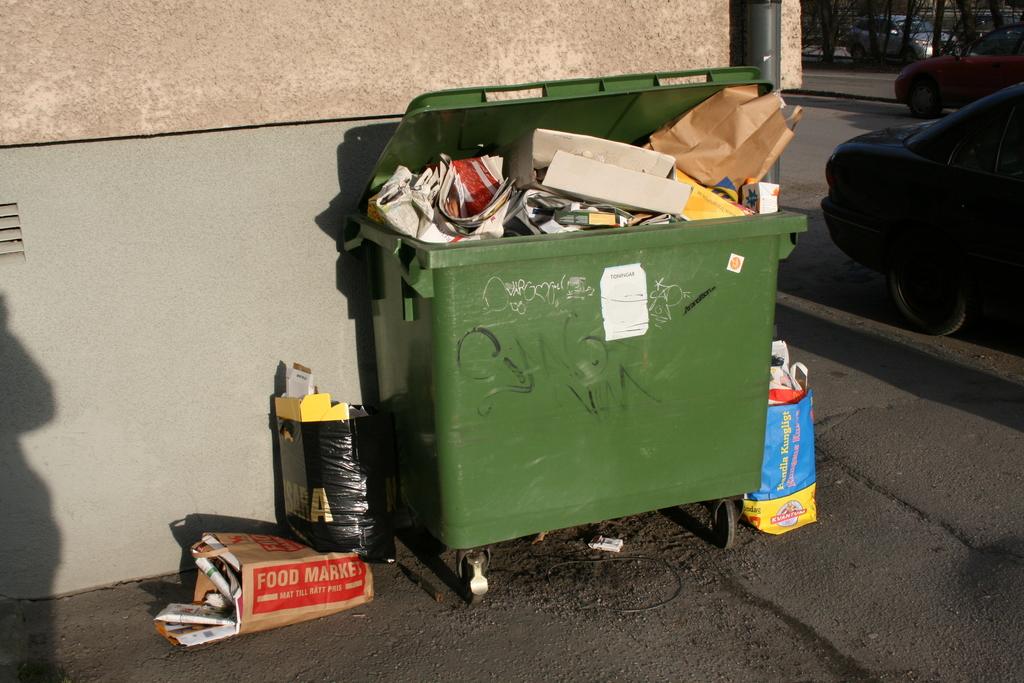What market is that bag from?
Your answer should be compact. Food market. Is this trash can full?
Ensure brevity in your answer.  Answering does not require reading text in the image. 